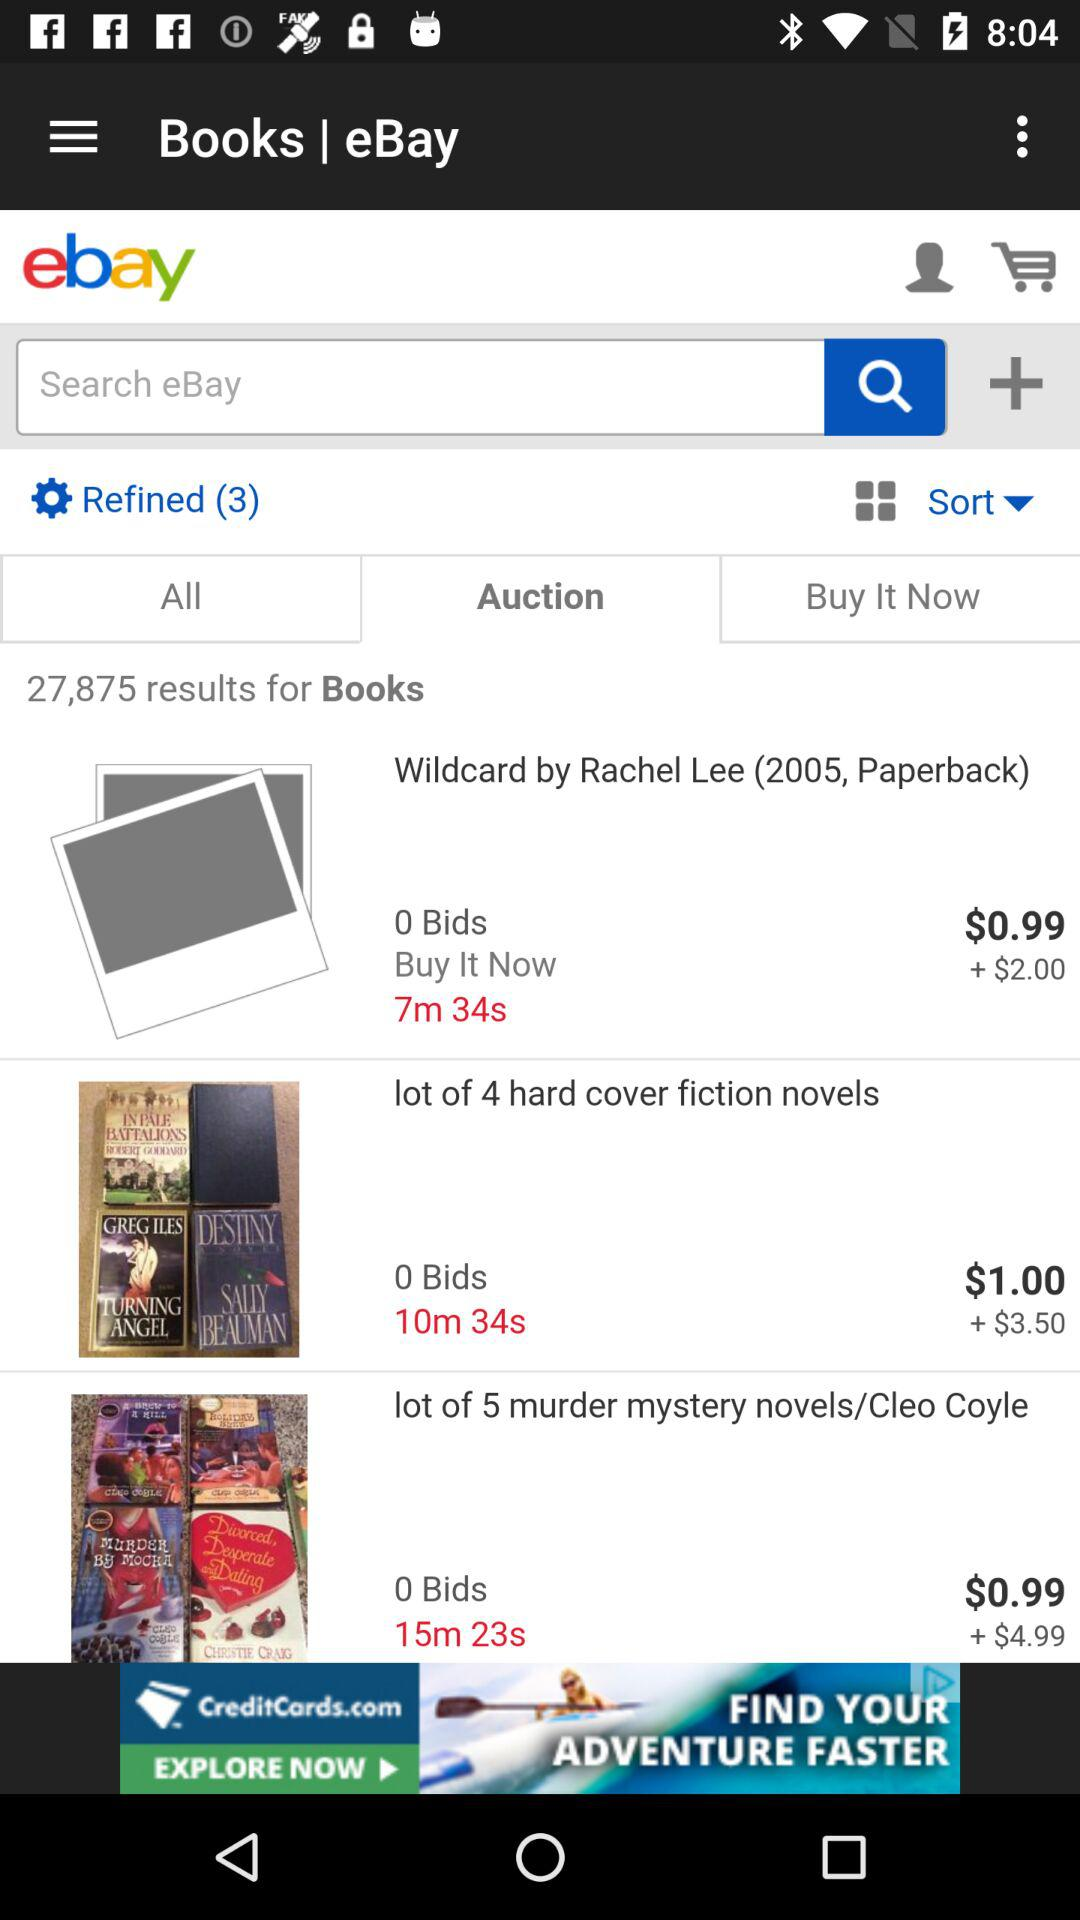What's the selected tab? The selected tab is "Auction". 